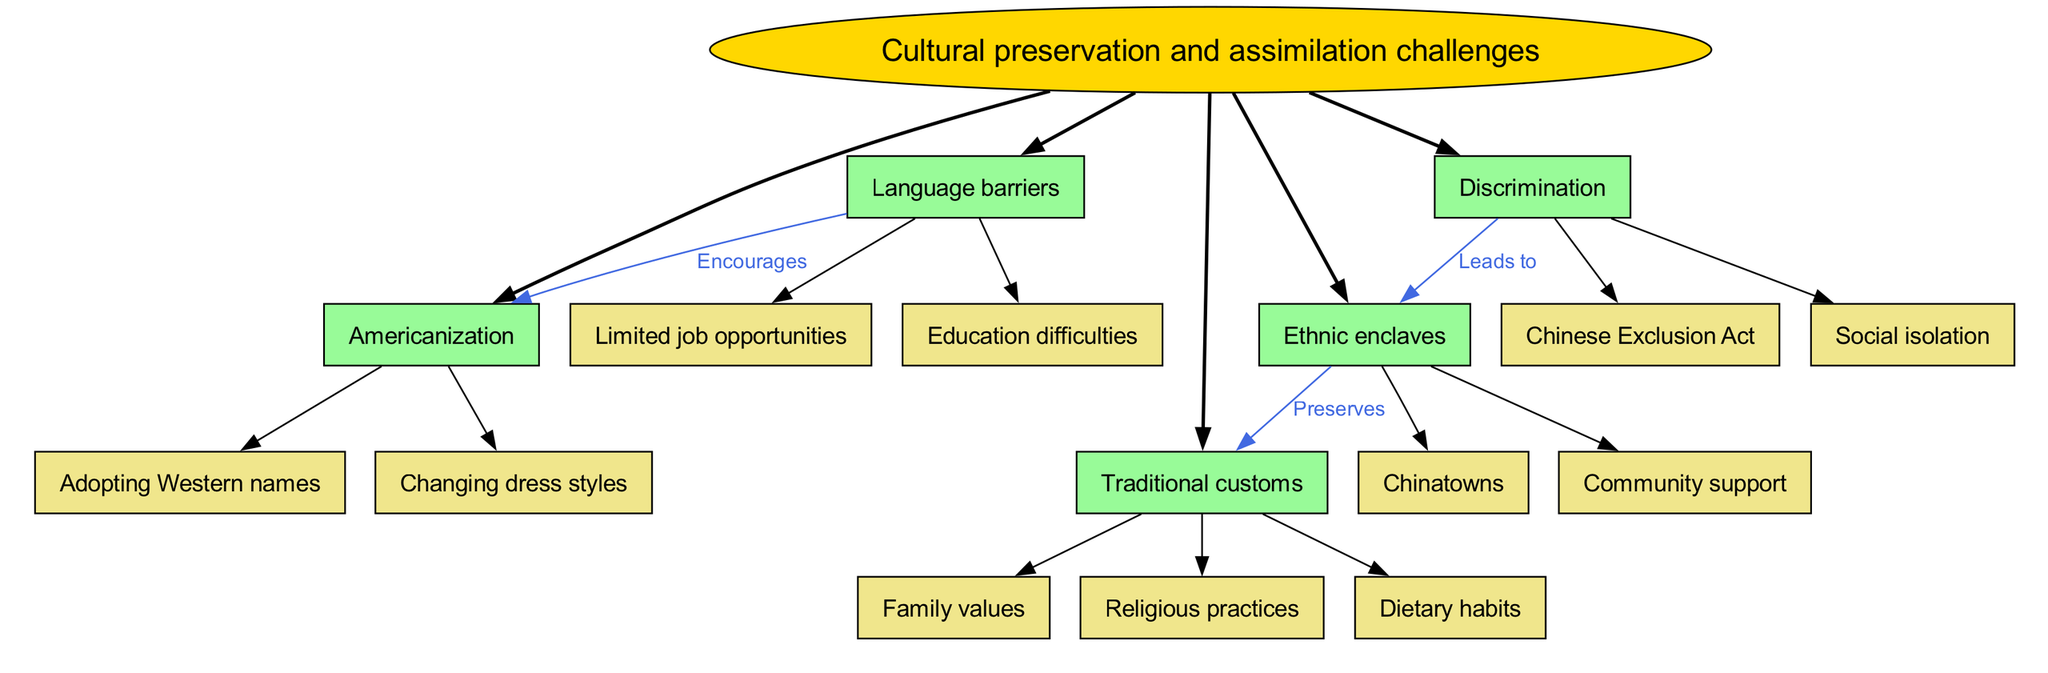What are the main nodes connected to the central concept? The central concept "Cultural preservation and assimilation challenges" connects to five main nodes: "Language barriers," "Traditional customs," "Ethnic enclaves," "Discrimination," and "Americanization."
Answer: Language barriers, Traditional customs, Ethnic enclaves, Discrimination, Americanization How many sub-nodes are under "Traditional customs"? The node "Traditional customs" has three sub-nodes: "Family values," "Religious practices," and "Dietary habits." Therefore, the count is three.
Answer: 3 What does "Discrimination" lead to? The diagram indicates that "Discrimination" leads to "Ethnic enclaves," showing a direct connection between these two nodes.
Answer: Ethnic enclaves Which main node encourages "Americanization"? The main node "Language barriers" is shown to encourage "Americanization," as indicated by the directed connection in the diagram.
Answer: Language barriers What label connects "Ethnic enclaves" and "Traditional customs"? The connection between "Ethnic enclaves" and "Traditional customs" is labeled as "Preserves," indicating a supportive relationship between these two aspects.
Answer: Preserves Which node is associated with "Chinese Exclusion Act"? The node "Discrimination" is associated with "Chinese Exclusion Act," as this is one of the sub-nodes listed under "Discrimination" in the diagram.
Answer: Discrimination How many main nodes are present in the diagram? There are five main nodes present in the diagram, as listed: "Language barriers," "Traditional customs," "Ethnic enclaves," "Discrimination," and "Americanization."
Answer: 5 What do "Chinatowns" represent within the context of the diagram? "Chinatowns" are classified as a sub-node under "Ethnic enclaves," representing a community space that supports cultural preservation for Chinese immigrants.
Answer: Ethnic enclaves What is a common outcome of the "Language barriers"? According to the diagram, "Language barriers" commonly result in "Limited job opportunities" and "Education difficulties," representing challenges faced by immigrants.
Answer: Limited job opportunities, Education difficulties 